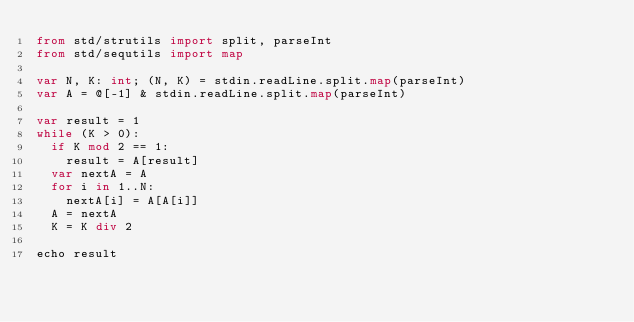<code> <loc_0><loc_0><loc_500><loc_500><_Nim_>from std/strutils import split, parseInt
from std/sequtils import map

var N, K: int; (N, K) = stdin.readLine.split.map(parseInt)
var A = @[-1] & stdin.readLine.split.map(parseInt)

var result = 1
while (K > 0):
  if K mod 2 == 1:
    result = A[result]
  var nextA = A
  for i in 1..N:
    nextA[i] = A[A[i]]
  A = nextA
  K = K div 2

echo result
</code> 